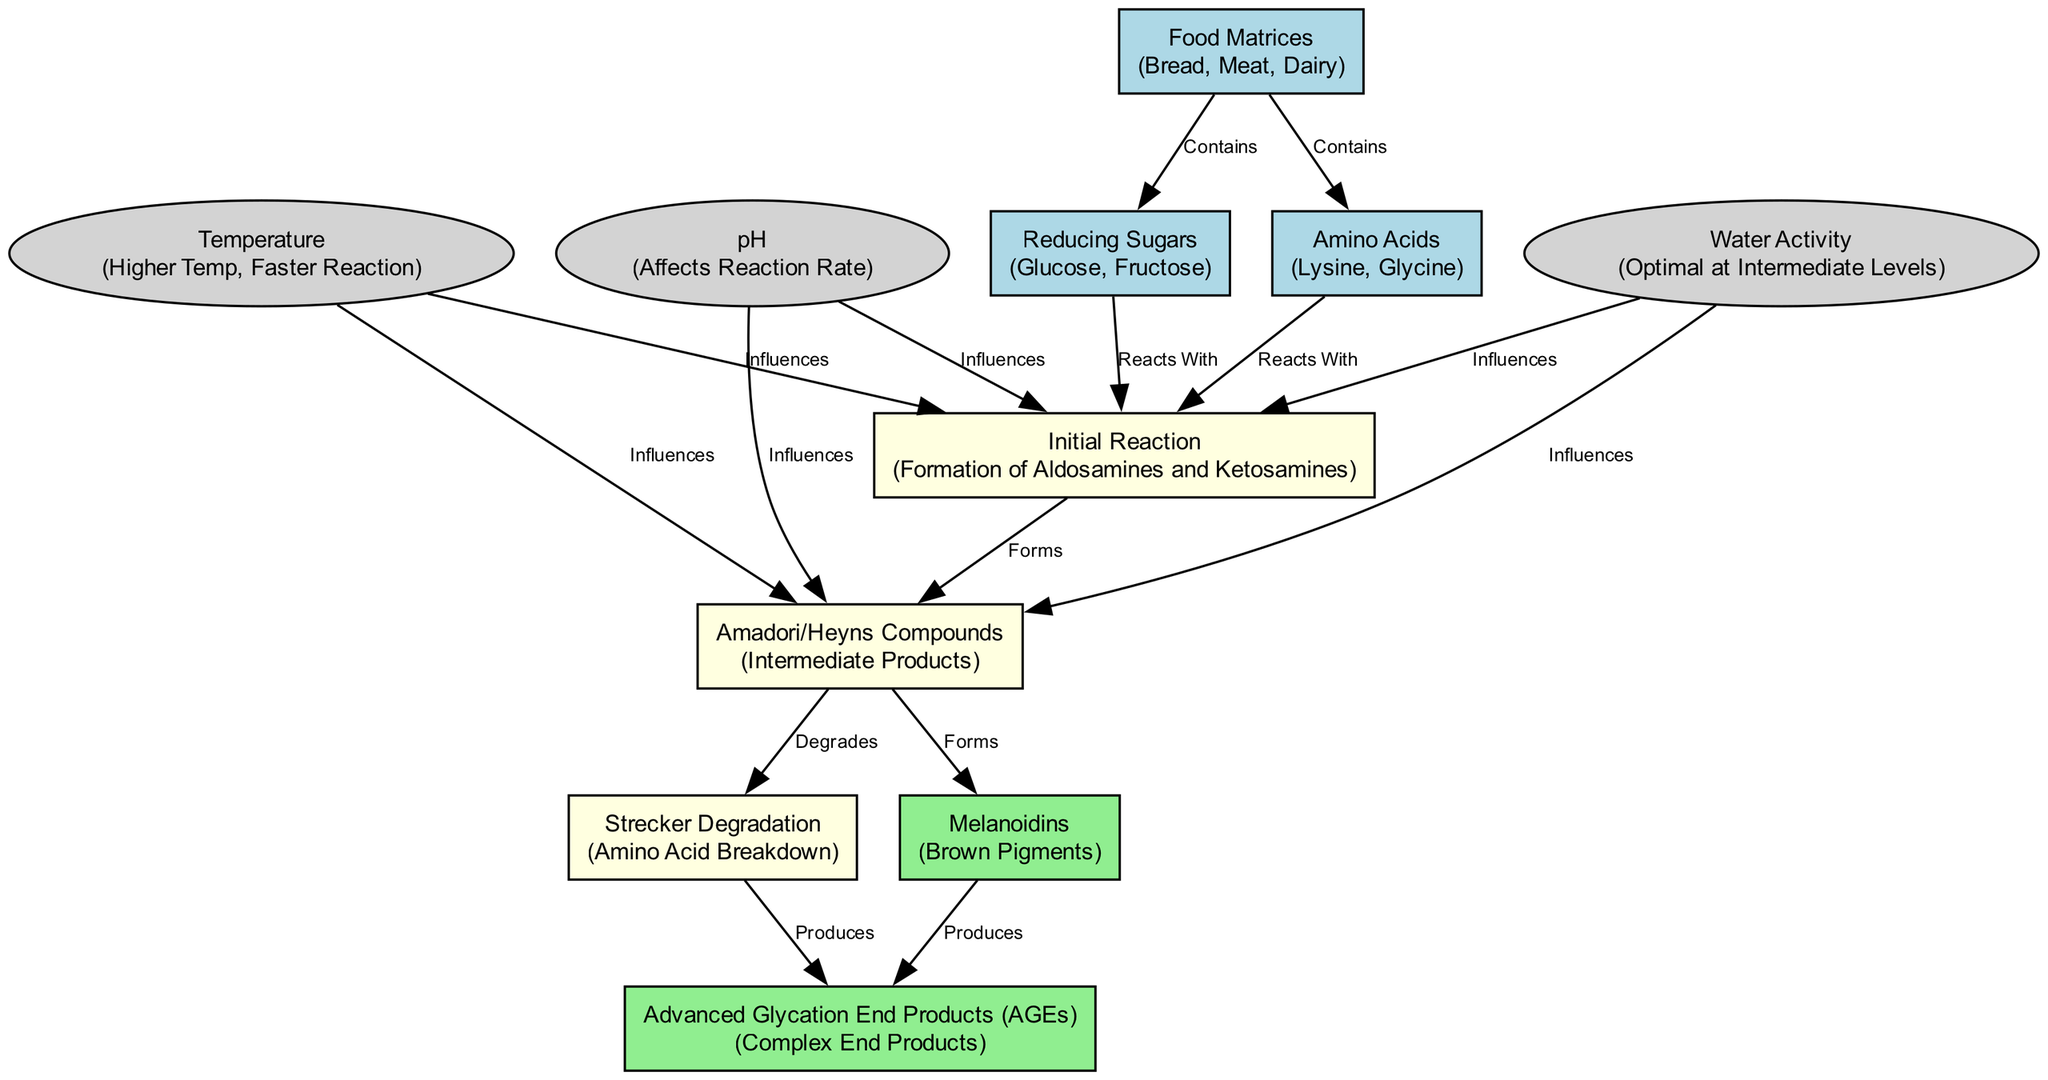What are the two primary reactants that initiate the Maillard reaction? The diagram indicates that the Maillard reaction begins with the interaction between reducing sugars and amino acids. Specifically, these are labeled as "Reducing Sugars" and "Amino Acids" in the nodes.
Answer: Reducing Sugars and Amino Acids What forms during the initial reaction of the Maillard process? According to the diagram, the initial reaction leads to the formation of Aldosamines and Ketosamines, identified in the section labeled "Initial Reaction."
Answer: Aldosamines and Ketosamines How many nodes are represented in the diagram? The diagram features a total of 11 nodes, which include the various reactants, products, and influencing factors. This can be counted directly from the nodes section of the diagram.
Answer: 11 Which factor is highlighted as influencing the initial reaction step? The diagram connects several factors to the "Initial Reaction" node. Specifically, Temperature, pH, and Water Activity are shown to influence this step, indicating their roles in affecting the reaction dynamics.
Answer: Temperature, pH, and Water Activity What is produced as a result of Strecker Degradation? The flow from the "Strecker Degradation" node indicates the production of Advanced Glycation End Products (AGEs), linking amino acid breakdown to this chemical product.
Answer: Advanced Glycation End Products (AGEs) What are the two steps that follow the formation of Amadori/Heyns Compounds? Following the formation of Amadori/Heyns Compounds, the process indicates two pathways: it can first degrade to produce Strecker Degradation products, and it can also lead to the formation of Melanoidins, which are both illustrated in the diagram.
Answer: Degrades to Strecker Degradation and Forms Melanoidins What type of compounds are Melanoidins classified as? The diagram describes Melanoidins as being brown pigments, showcasing their role as visually impactful products of the Maillard reaction, implying their significance in food chemistry.
Answer: Brown Pigments In the context of food matrices, what common items do they contain? The diagram indicates that food matrices such as bread, meat, and dairy contain both reducing sugars and amino acids, which are the essential reactants in the Maillard reaction.
Answer: Bread, Meat, and Dairy How does high temperature affect the Maillard reaction? The diagram specifies that higher temperature results in a faster reaction, demonstrating the temperature's influence on the rate of the Maillard reaction process.
Answer: Faster Reaction 